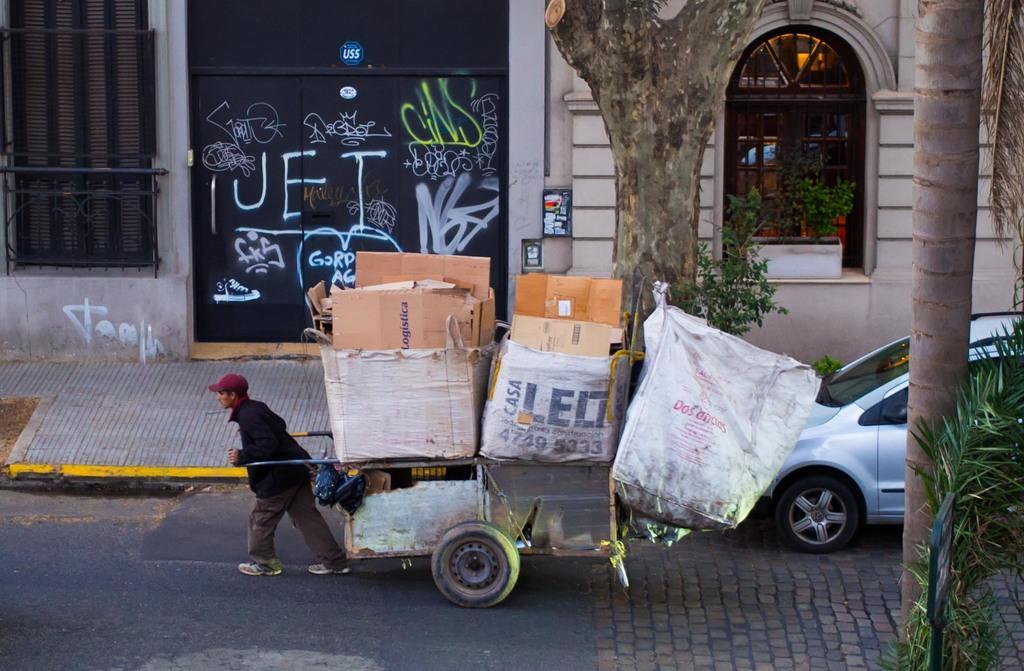Please provide a concise description of this image. Here I can see a man holding a trolley in the hands and walking on the road towards the left side. On the trolley I can see few bags. On the right side, I can see a car and also a tree trunk. In the background there is a building and a tree. 